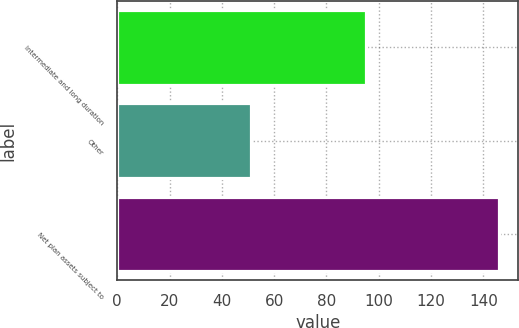<chart> <loc_0><loc_0><loc_500><loc_500><bar_chart><fcel>Intermediate and long duration<fcel>Other<fcel>Net plan assets subject to<nl><fcel>95<fcel>51<fcel>146<nl></chart> 